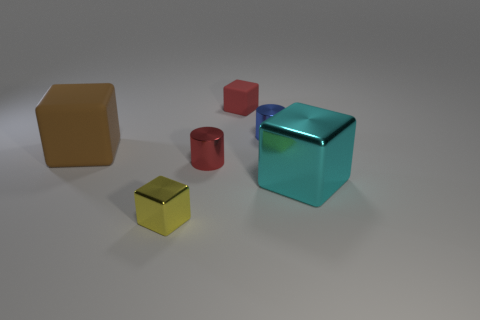Subtract all big brown rubber cubes. How many cubes are left? 3 Add 1 tiny green metal cylinders. How many objects exist? 7 Subtract all blue cylinders. How many cylinders are left? 1 Subtract 2 cubes. How many cubes are left? 2 Subtract all cylinders. How many objects are left? 4 Subtract all small yellow things. Subtract all red shiny objects. How many objects are left? 4 Add 4 yellow objects. How many yellow objects are left? 5 Add 3 big green cubes. How many big green cubes exist? 3 Subtract 1 blue cylinders. How many objects are left? 5 Subtract all cyan cylinders. Subtract all purple blocks. How many cylinders are left? 2 